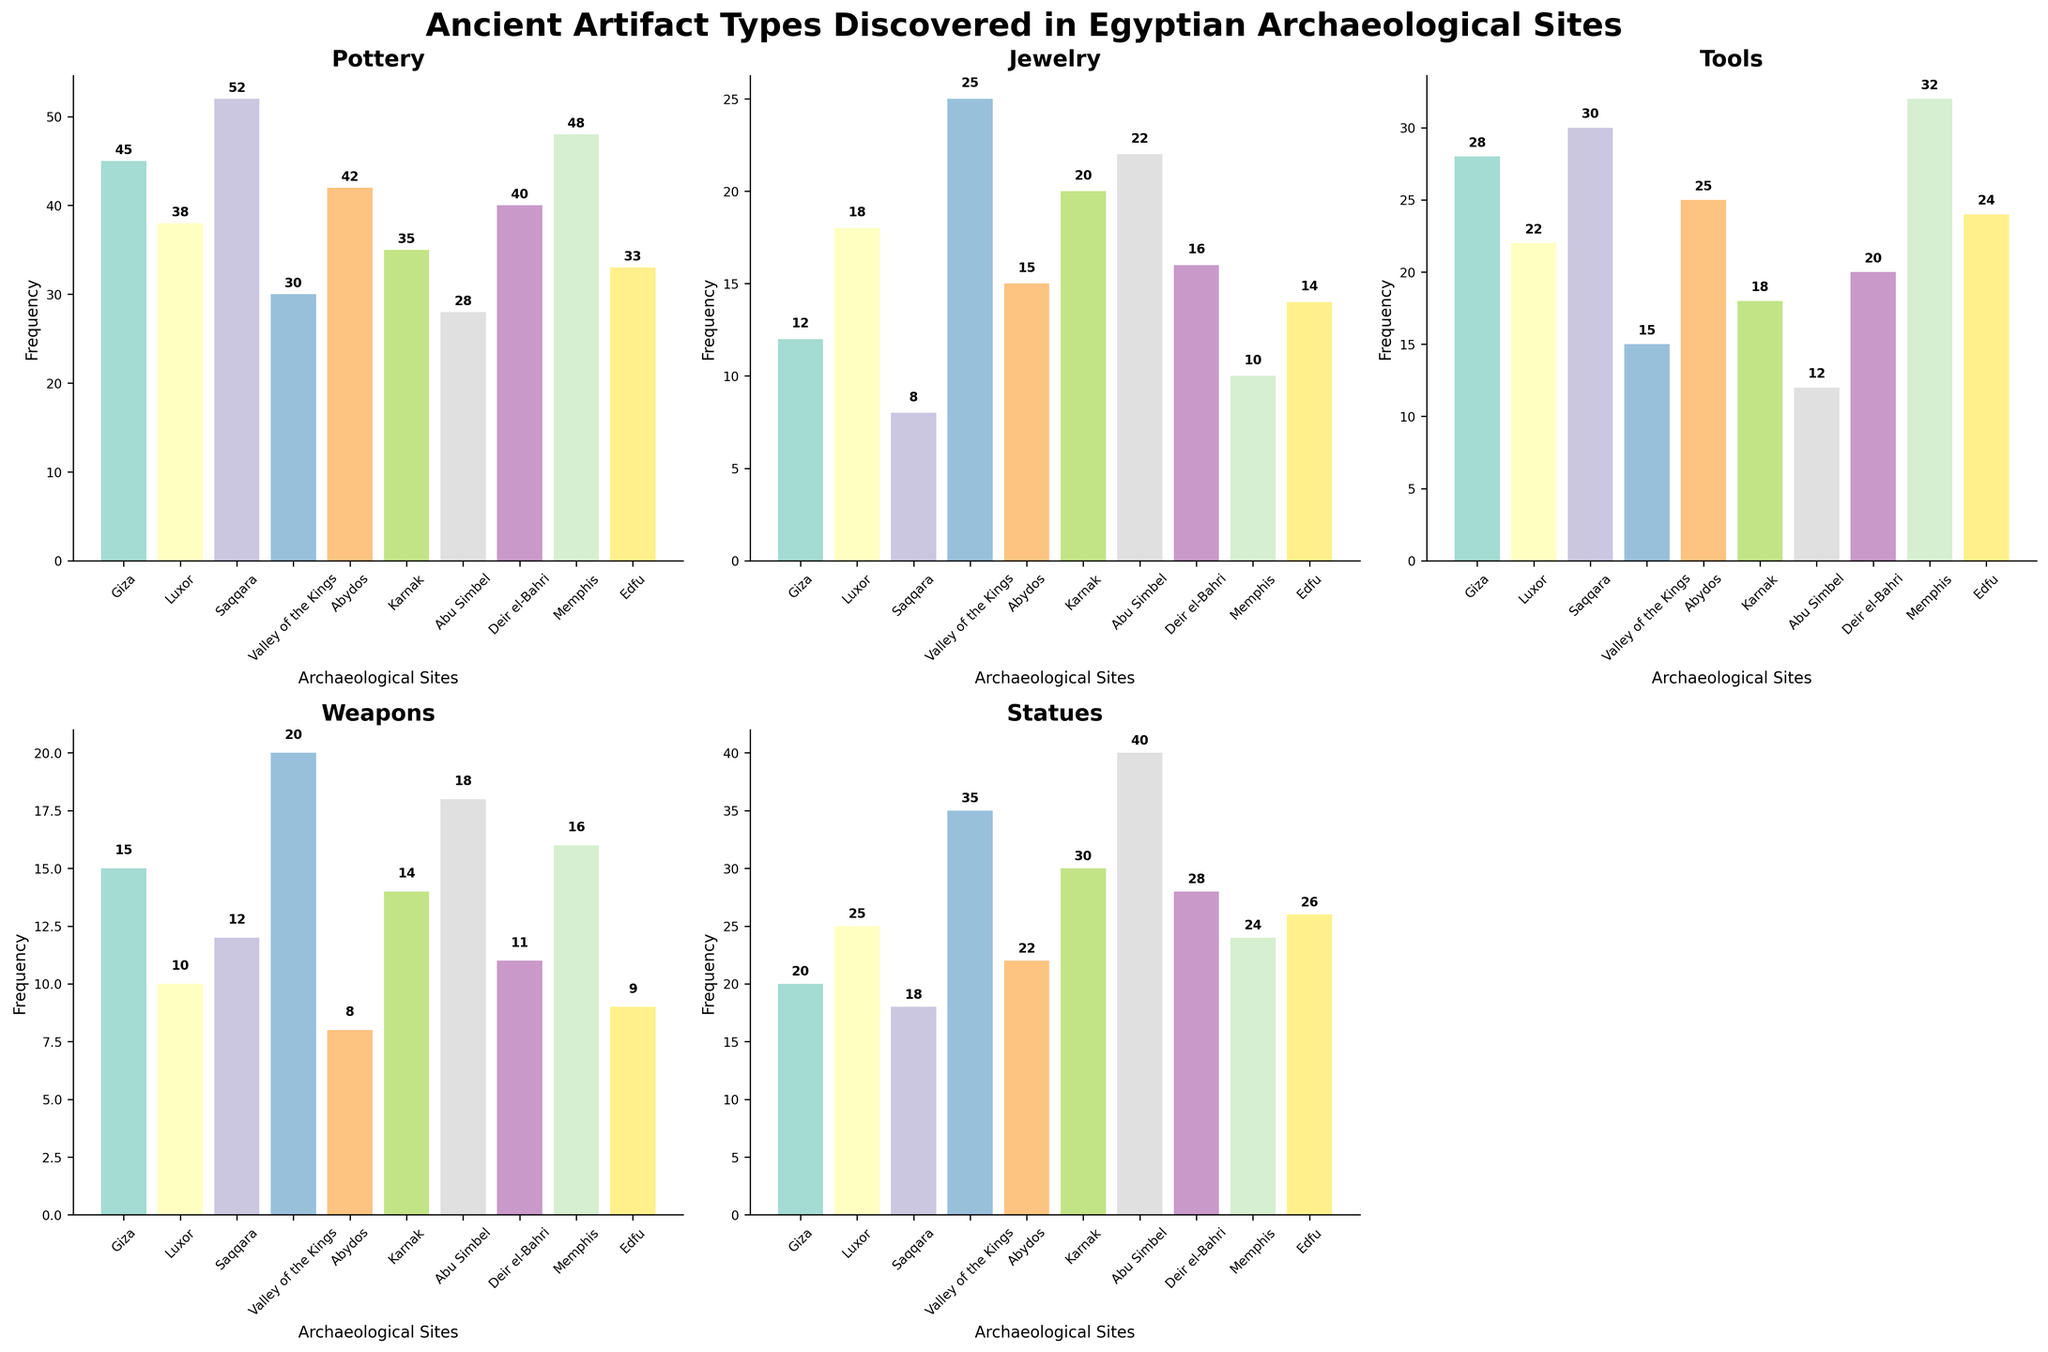What is the title of the figure? The title is usually placed at the top of the figure. In this case, the title reads "Ancient Artifact Types Discovered in Egyptian Archaeological Sites".
Answer: Ancient Artifact Types Discovered in Egyptian Archaeological Sites How many archaeological sites are displayed in each subplot? There are ten sites listed in each subplot: Giza, Luxor, Saqqara, Valley of the Kings, Abydos, Karnak, Abu Simbel, Deir el-Bahri, Memphis, and Edfu.
Answer: 10 Which archaeological site has the highest frequency of Weapon artifacts? By observing the subplot related to Weapons, we can see that Abu Simbel has the highest weapon frequency with 18 artifacts.
Answer: Abu Simbel What is the total number of Jewelry artifacts discovered in all sites combined? Sum the number of Jewelry artifacts across all sites. This gives us: 12 (Giza) + 18 (Luxor) + 8 (Saqqara) + 25 (Valley of the Kings) + 15 (Abydos) + 20 (Karnak) + 22 (Abu Simbel) + 16 (Deir el-Bahri) + 10 (Memphis) + 14 (Edfu) = 160.
Answer: 160 Which site discovered more Pottery artifacts: Giza or Saqqara? Looking at the Pottery subplot, Giza has 45 artifacts while Saqqara has 52. Saqqara has more Pottery artifacts.
Answer: Saqqara What is the average number of Statues discovered per site? By summing the number of Statues across all sites and then dividing by the number of sites, we get: (20 + 25 + 18 + 35 + 22 + 30 + 40 + 28 + 24 + 26) / 10 = 268 / 10 = 26.8.
Answer: 26.8 Which artifact type has the least frequency in Saqqara? In the Saqqara subplot, Jewelry has the least frequency with 8 artifacts.
Answer: Jewelry How many more Tools were found in Memphis compared to Edfu? From the Tools subplot, Memphis has 32 artifacts, and Edfu has 24. The difference is 32 - 24 = 8.
Answer: 8 Are there more Statues or Weapons found in the Valley of the Kings? Comparing the Statues and Weapons subplots, the Valley of the Kings has 35 Statues and 20 Weapons. Statues are more frequent.
Answer: Statues Which artifacts type shows the highest variability in frequencies across sites? Observing the subplots, Statues show the highest variability with a range between 18 and 40 artifacts across the sites.
Answer: Statues 